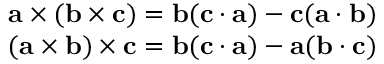<formula> <loc_0><loc_0><loc_500><loc_500>{ \begin{array} { r } { a \times ( b \times c ) = b ( c \cdot a ) - c ( a \cdot b ) } \\ { ( a \times b ) \times c = b ( c \cdot a ) - a ( b \cdot c ) } \end{array} }</formula> 